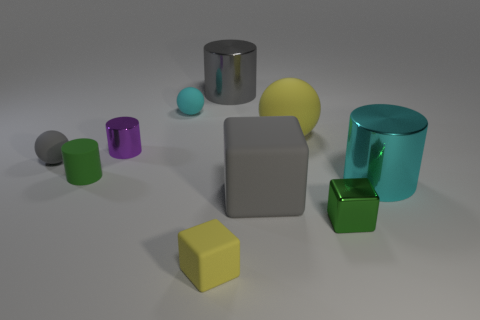Subtract all yellow cylinders. Subtract all blue spheres. How many cylinders are left? 4 Subtract all blocks. How many objects are left? 7 Add 1 gray shiny cylinders. How many gray shiny cylinders are left? 2 Add 7 large green metal cylinders. How many large green metal cylinders exist? 7 Subtract 1 yellow spheres. How many objects are left? 9 Subtract all tiny yellow matte things. Subtract all tiny purple matte blocks. How many objects are left? 9 